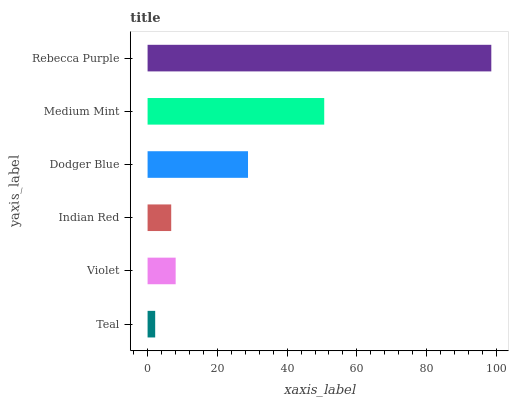Is Teal the minimum?
Answer yes or no. Yes. Is Rebecca Purple the maximum?
Answer yes or no. Yes. Is Violet the minimum?
Answer yes or no. No. Is Violet the maximum?
Answer yes or no. No. Is Violet greater than Teal?
Answer yes or no. Yes. Is Teal less than Violet?
Answer yes or no. Yes. Is Teal greater than Violet?
Answer yes or no. No. Is Violet less than Teal?
Answer yes or no. No. Is Dodger Blue the high median?
Answer yes or no. Yes. Is Violet the low median?
Answer yes or no. Yes. Is Indian Red the high median?
Answer yes or no. No. Is Medium Mint the low median?
Answer yes or no. No. 